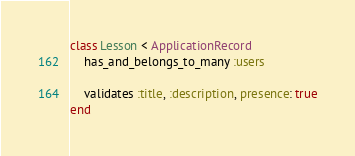Convert code to text. <code><loc_0><loc_0><loc_500><loc_500><_Ruby_>class Lesson < ApplicationRecord
    has_and_belongs_to_many :users

    validates :title, :description, presence: true
end
</code> 